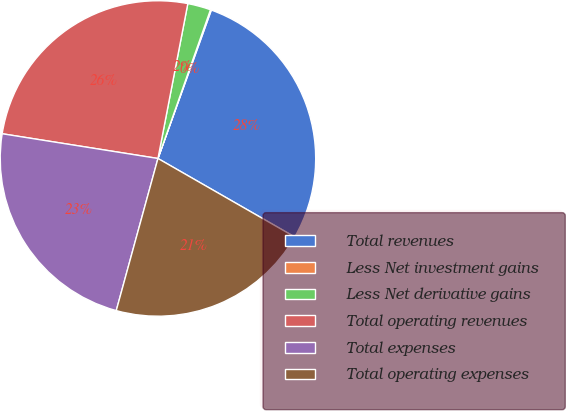Convert chart to OTSL. <chart><loc_0><loc_0><loc_500><loc_500><pie_chart><fcel>Total revenues<fcel>Less Net investment gains<fcel>Less Net derivative gains<fcel>Total operating revenues<fcel>Total expenses<fcel>Total operating expenses<nl><fcel>27.8%<fcel>0.09%<fcel>2.37%<fcel>25.53%<fcel>23.25%<fcel>20.97%<nl></chart> 